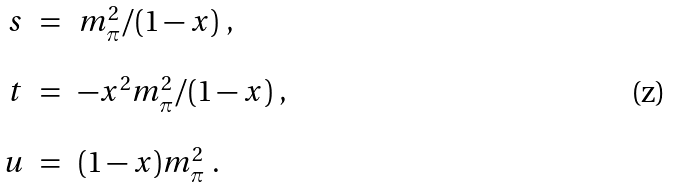<formula> <loc_0><loc_0><loc_500><loc_500>\begin{array} { r c l } s & = & m _ { \pi } ^ { 2 } / ( 1 - x ) \ , \\ \\ t & = & - x ^ { 2 } m _ { \pi } ^ { 2 } / ( 1 - x ) \ , \\ \\ u & = & ( 1 - x ) m _ { \pi } ^ { 2 } \ . \end{array}</formula> 